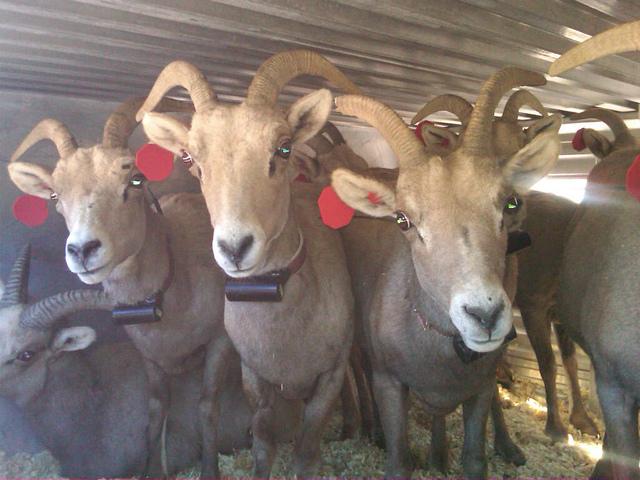Are these goats?
Short answer required. Yes. Do all of the sheep have horns?
Short answer required. Yes. How many animals are there?
Be succinct. 5. Would a troll find these tasty?
Be succinct. Yes. 